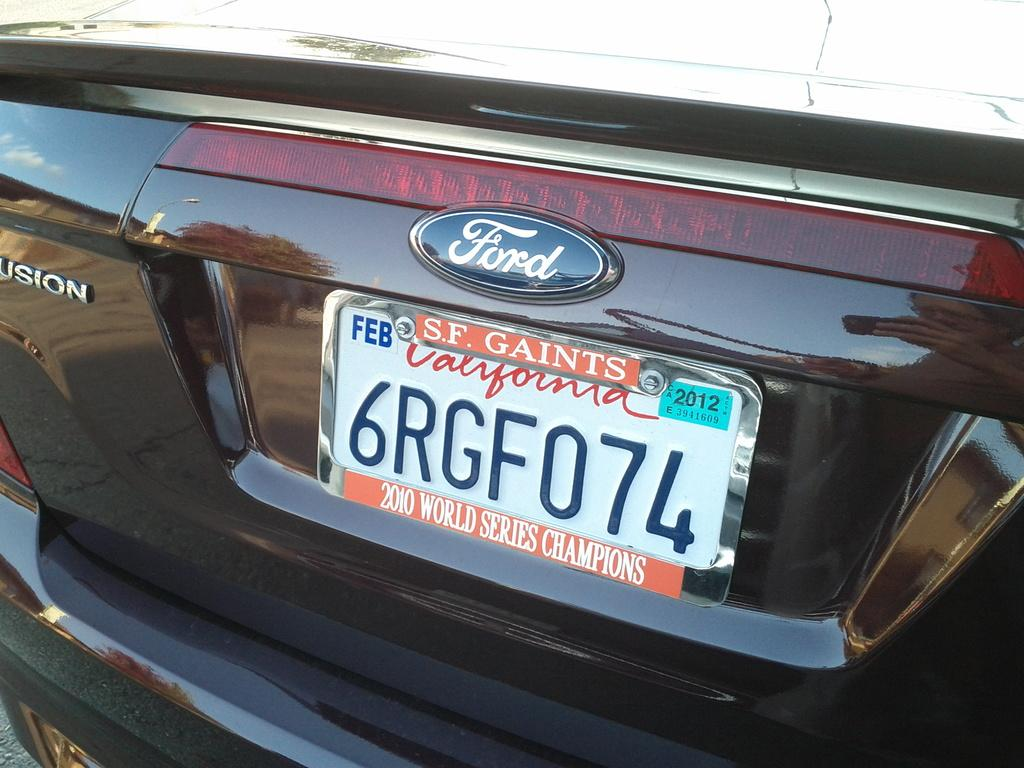<image>
Relay a brief, clear account of the picture shown. White California license plate which says 6RGF074 on it. 